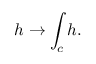Convert formula to latex. <formula><loc_0><loc_0><loc_500><loc_500>h \to \int _ { c } h .</formula> 